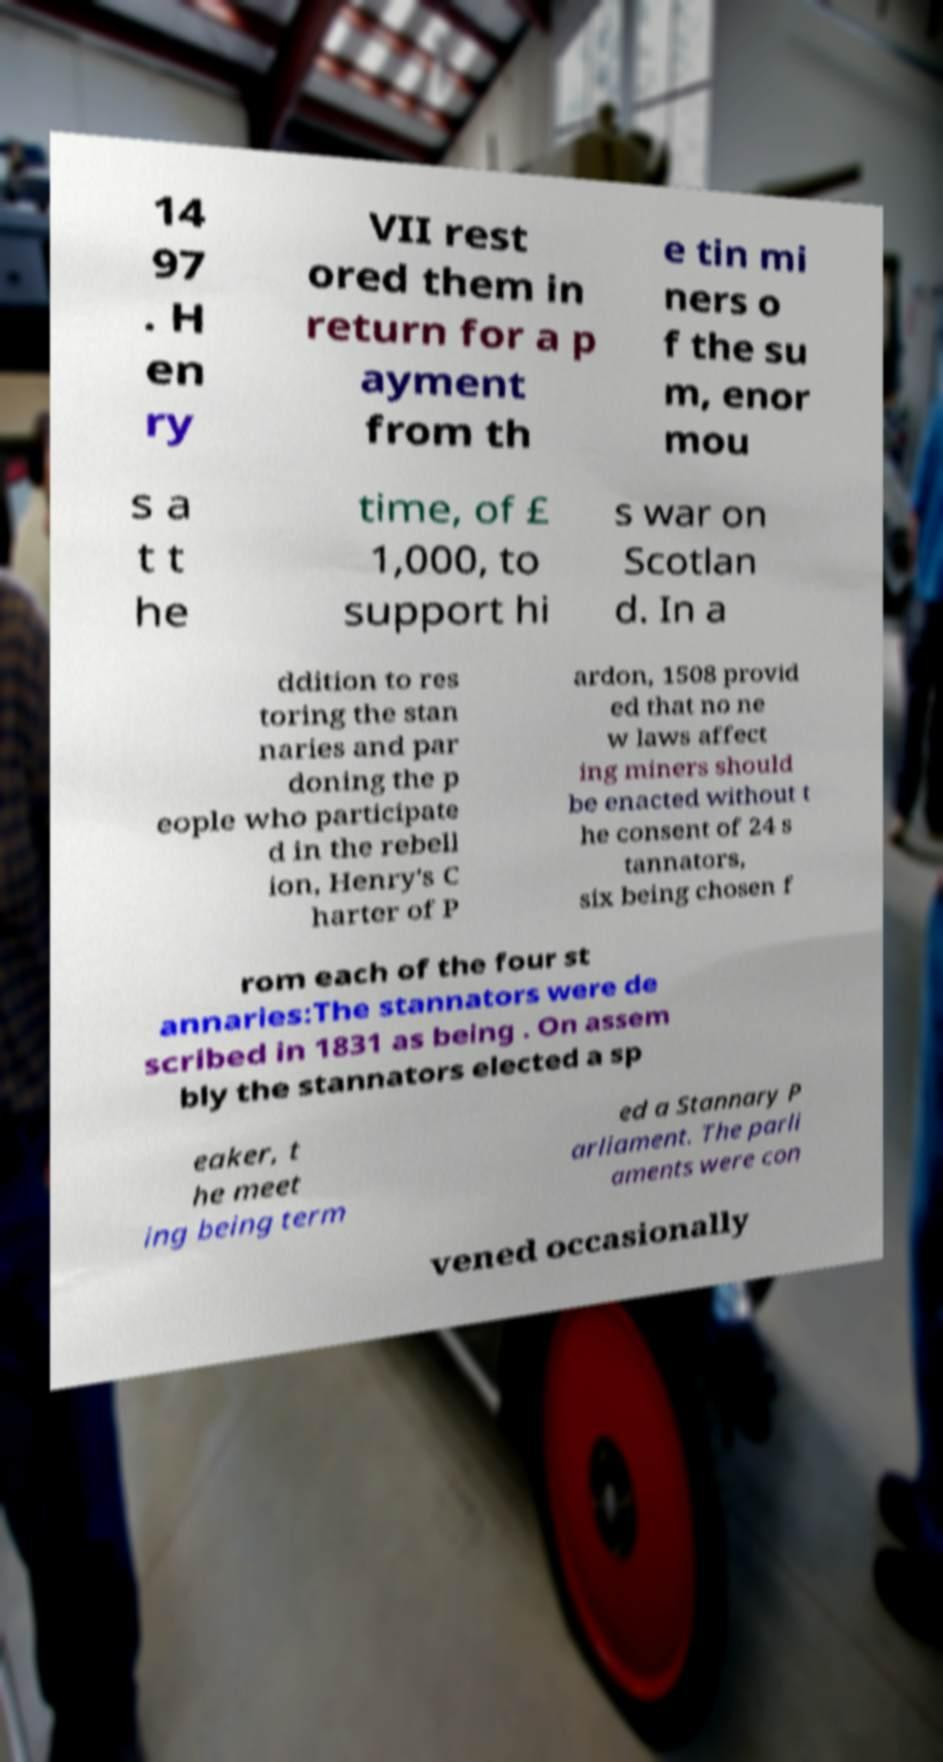Can you accurately transcribe the text from the provided image for me? 14 97 . H en ry VII rest ored them in return for a p ayment from th e tin mi ners o f the su m, enor mou s a t t he time, of £ 1,000, to support hi s war on Scotlan d. In a ddition to res toring the stan naries and par doning the p eople who participate d in the rebell ion, Henry's C harter of P ardon, 1508 provid ed that no ne w laws affect ing miners should be enacted without t he consent of 24 s tannators, six being chosen f rom each of the four st annaries:The stannators were de scribed in 1831 as being . On assem bly the stannators elected a sp eaker, t he meet ing being term ed a Stannary P arliament. The parli aments were con vened occasionally 